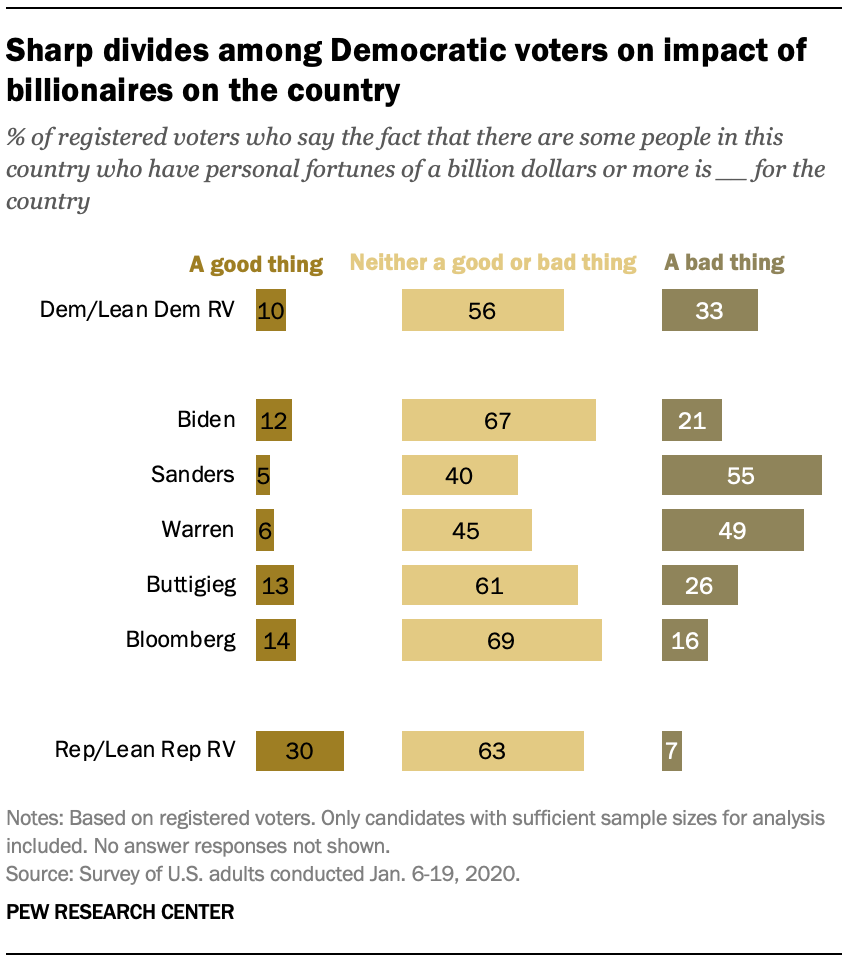Mention a couple of crucial points in this snapshot. The product of all the bars whose value is above 66 is 4623. 